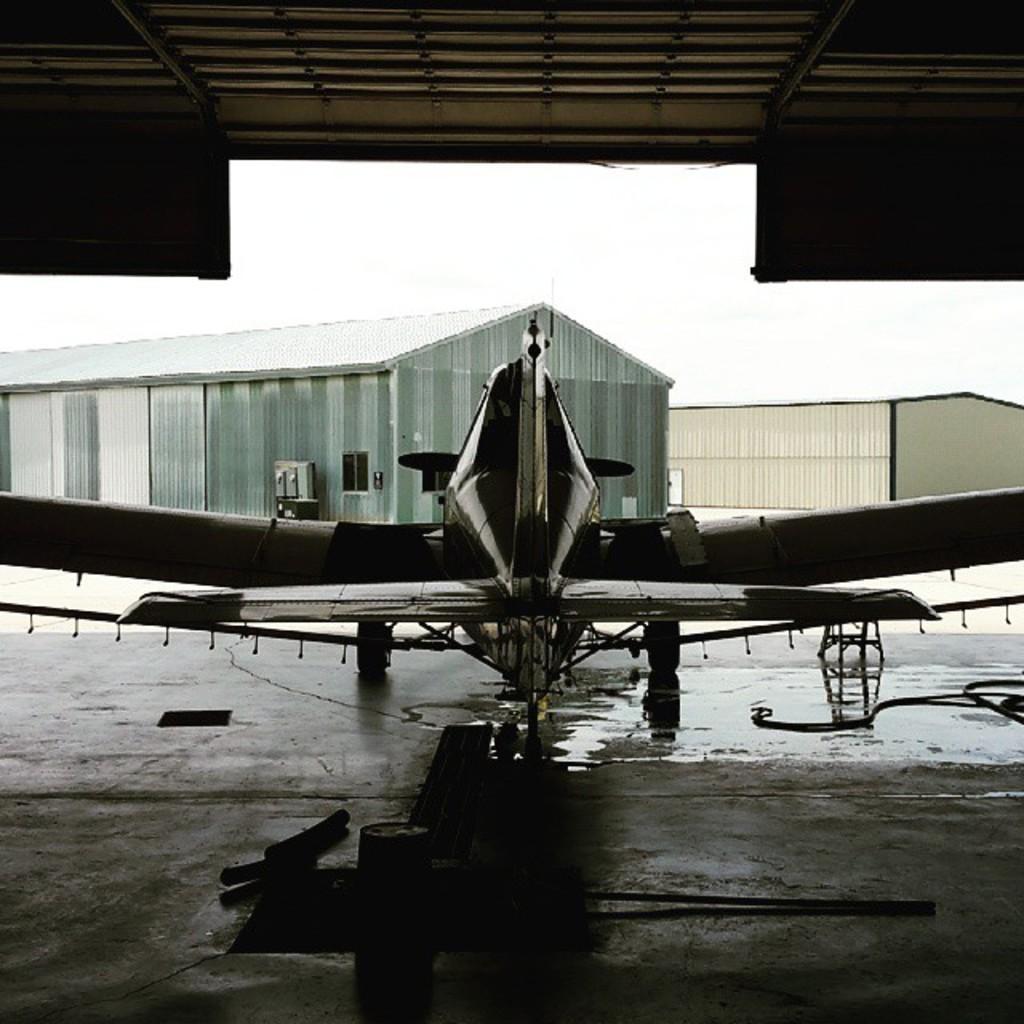How would you summarize this image in a sentence or two? At the bottom of the image on the floor there is a plane. And also there are some other things. In front of the plane there are sheds. At the top of the image there is a ceiling. 